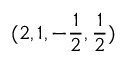Convert formula to latex. <formula><loc_0><loc_0><loc_500><loc_500>( 2 , 1 , - \frac { 1 } { 2 } , \frac { 1 } { 2 } )</formula> 